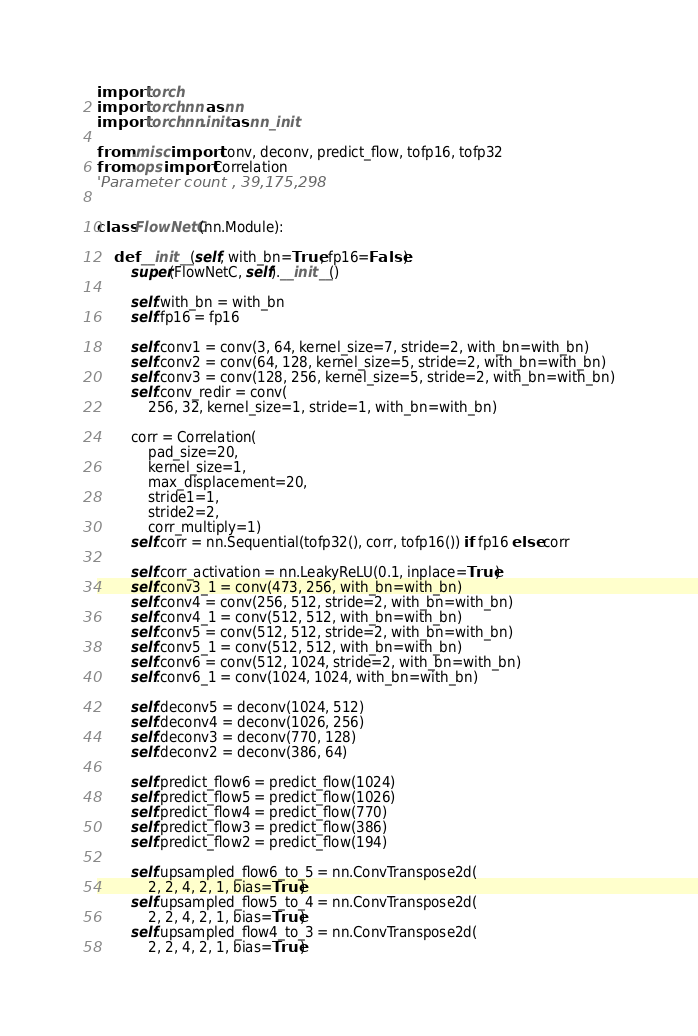<code> <loc_0><loc_0><loc_500><loc_500><_Python_>import torch
import torch.nn as nn
import torch.nn.init as nn_init

from .misc import conv, deconv, predict_flow, tofp16, tofp32
from .ops import Correlation
'Parameter count , 39,175,298 '


class FlowNetC(nn.Module):

    def __init__(self, with_bn=True, fp16=False):
        super(FlowNetC, self).__init__()

        self.with_bn = with_bn
        self.fp16 = fp16

        self.conv1 = conv(3, 64, kernel_size=7, stride=2, with_bn=with_bn)
        self.conv2 = conv(64, 128, kernel_size=5, stride=2, with_bn=with_bn)
        self.conv3 = conv(128, 256, kernel_size=5, stride=2, with_bn=with_bn)
        self.conv_redir = conv(
            256, 32, kernel_size=1, stride=1, with_bn=with_bn)

        corr = Correlation(
            pad_size=20,
            kernel_size=1,
            max_displacement=20,
            stride1=1,
            stride2=2,
            corr_multiply=1)
        self.corr = nn.Sequential(tofp32(), corr, tofp16()) if fp16 else corr

        self.corr_activation = nn.LeakyReLU(0.1, inplace=True)
        self.conv3_1 = conv(473, 256, with_bn=with_bn)
        self.conv4 = conv(256, 512, stride=2, with_bn=with_bn)
        self.conv4_1 = conv(512, 512, with_bn=with_bn)
        self.conv5 = conv(512, 512, stride=2, with_bn=with_bn)
        self.conv5_1 = conv(512, 512, with_bn=with_bn)
        self.conv6 = conv(512, 1024, stride=2, with_bn=with_bn)
        self.conv6_1 = conv(1024, 1024, with_bn=with_bn)

        self.deconv5 = deconv(1024, 512)
        self.deconv4 = deconv(1026, 256)
        self.deconv3 = deconv(770, 128)
        self.deconv2 = deconv(386, 64)

        self.predict_flow6 = predict_flow(1024)
        self.predict_flow5 = predict_flow(1026)
        self.predict_flow4 = predict_flow(770)
        self.predict_flow3 = predict_flow(386)
        self.predict_flow2 = predict_flow(194)

        self.upsampled_flow6_to_5 = nn.ConvTranspose2d(
            2, 2, 4, 2, 1, bias=True)
        self.upsampled_flow5_to_4 = nn.ConvTranspose2d(
            2, 2, 4, 2, 1, bias=True)
        self.upsampled_flow4_to_3 = nn.ConvTranspose2d(
            2, 2, 4, 2, 1, bias=True)</code> 